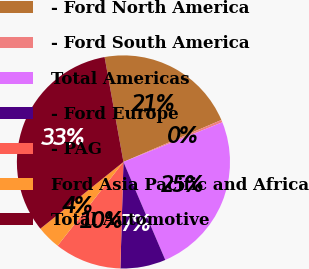Convert chart to OTSL. <chart><loc_0><loc_0><loc_500><loc_500><pie_chart><fcel>- Ford North America<fcel>- Ford South America<fcel>Total Americas<fcel>- Ford Europe<fcel>- PAG<fcel>Ford Asia Pacific and Africa<fcel>Total Automotive<nl><fcel>21.39%<fcel>0.37%<fcel>24.65%<fcel>6.88%<fcel>10.14%<fcel>3.63%<fcel>32.94%<nl></chart> 